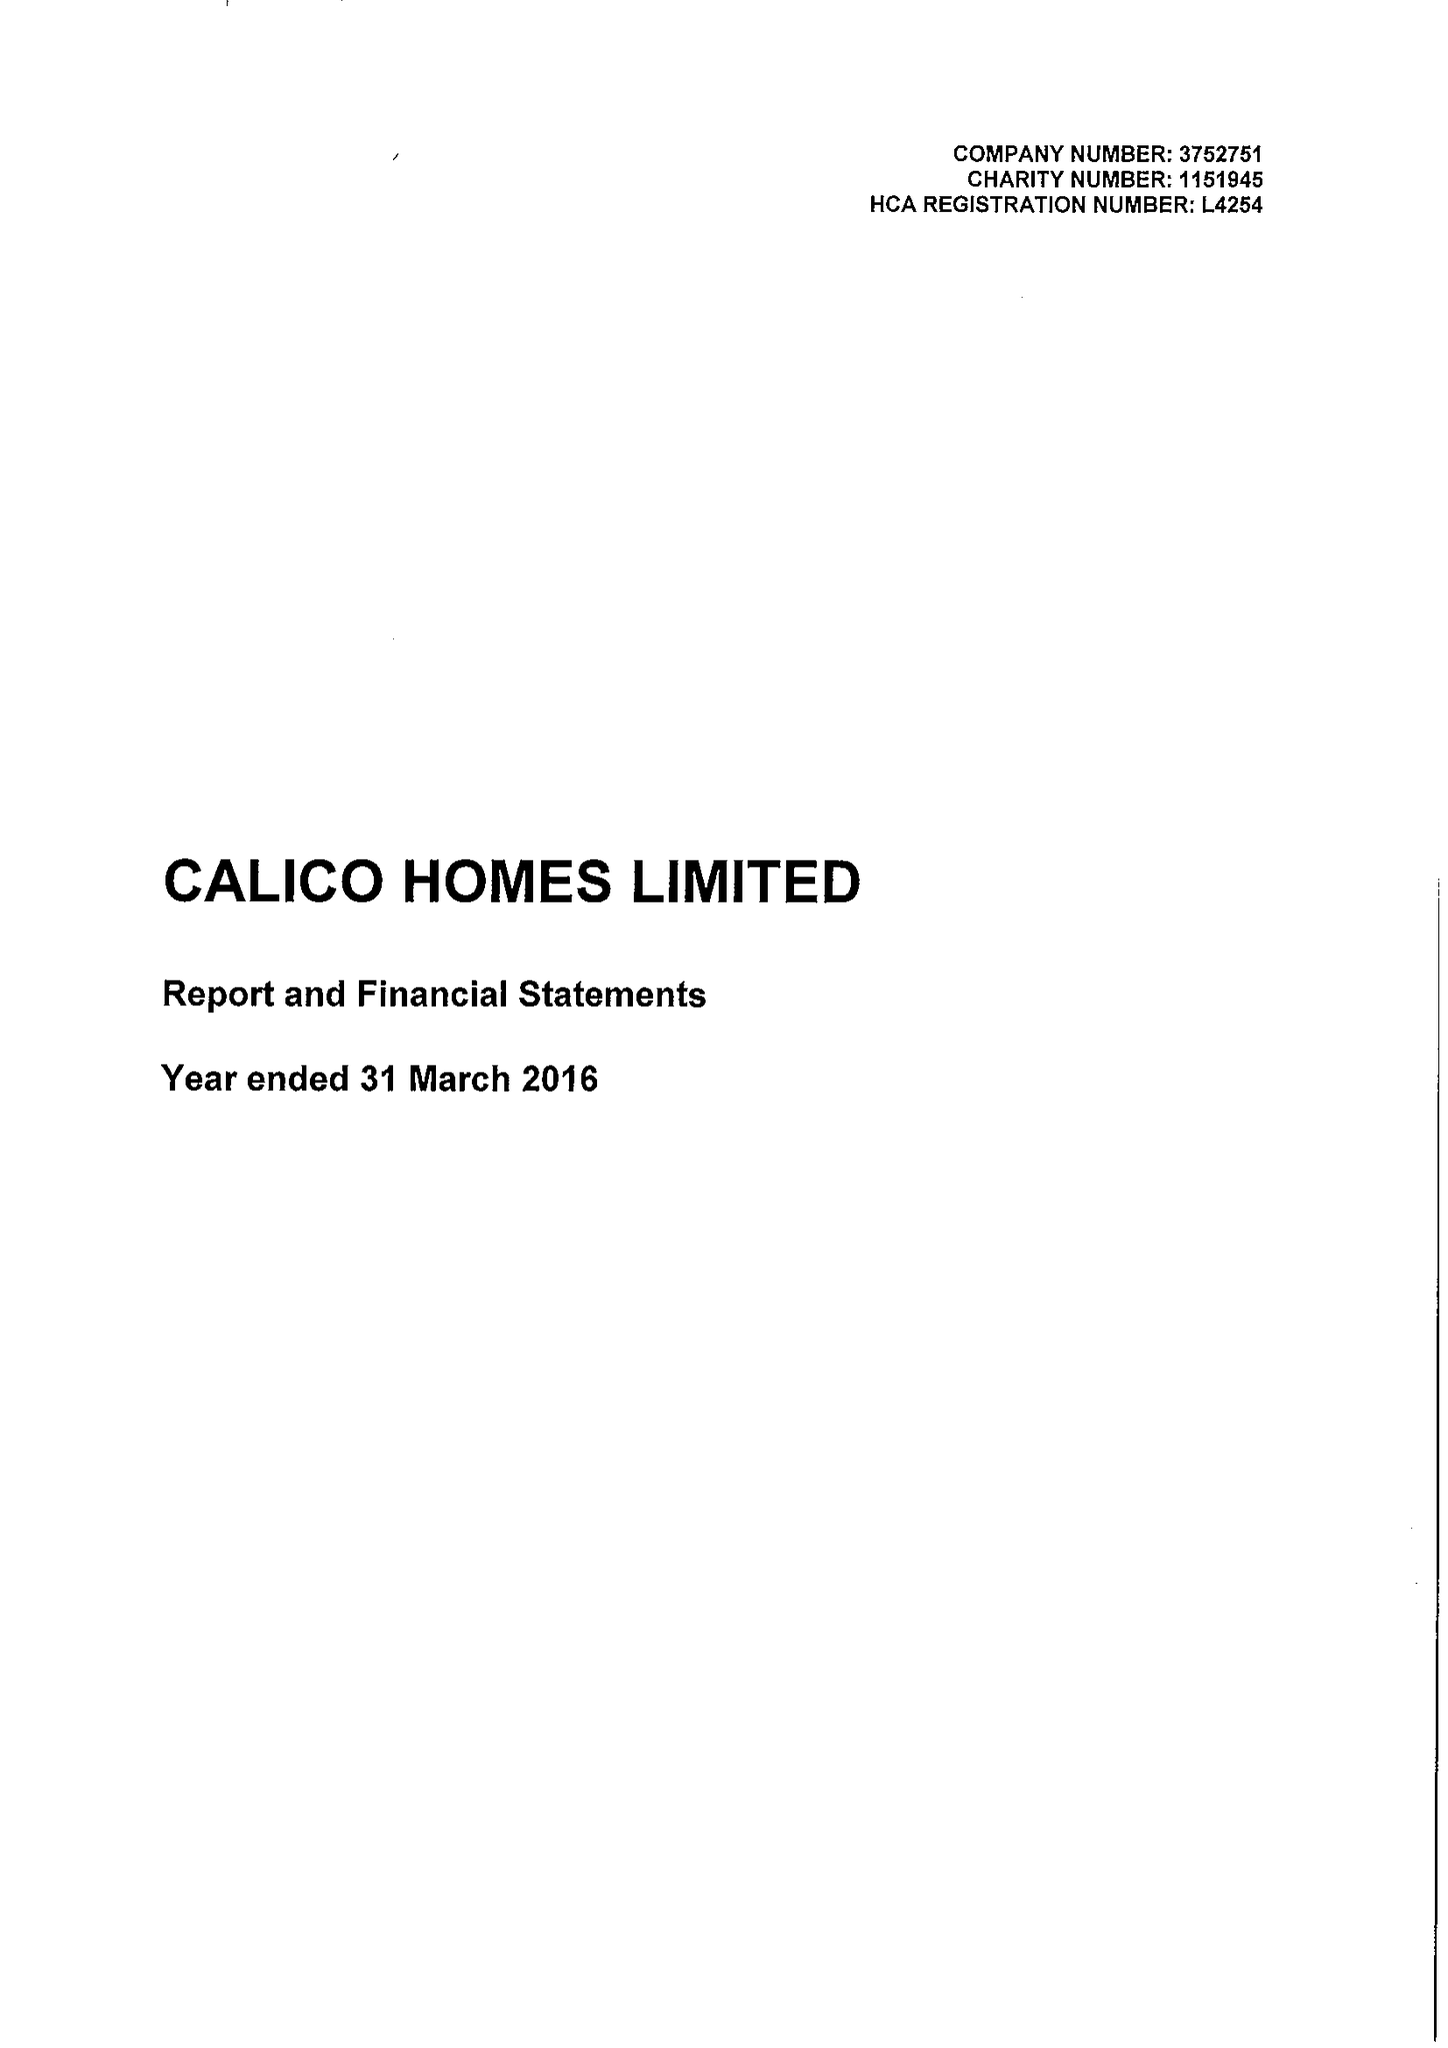What is the value for the address__street_line?
Answer the question using a single word or phrase. CROFT STREET 